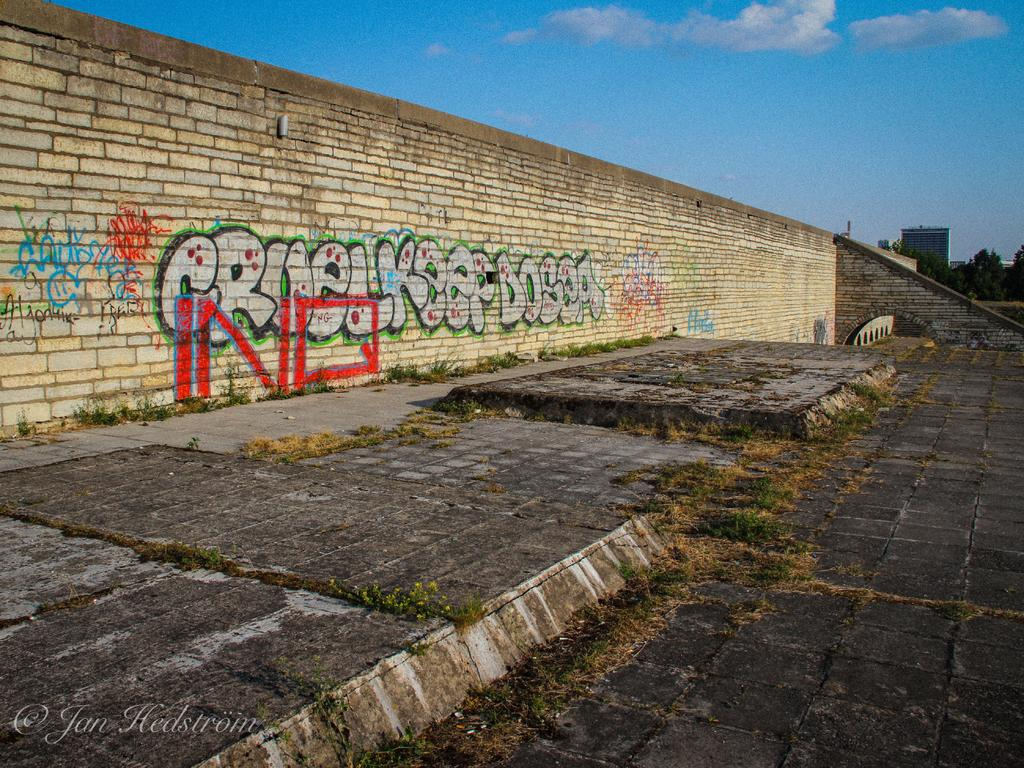What can be seen in the foreground of the image? There is a path in the image. What is visible in the background of the image? There is a wall in the background of the image. What color is the sky in the image? The sky is blue in the image. How many times does the wall shake in the image? The wall does not shake in the image; it is stationary. What is the fifth of the path in the image? There is no mention of a fifth or any other fraction in the image or the provided facts. 